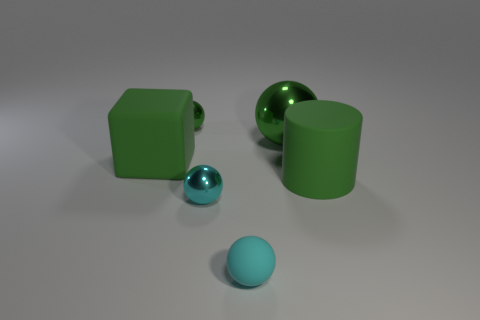How big is the matte sphere?
Your answer should be compact. Small. There is a green object that is on the left side of the cyan shiny sphere and behind the big green cube; what shape is it?
Give a very brief answer. Sphere. What is the color of the other large thing that is the same shape as the cyan matte object?
Provide a short and direct response. Green. How many things are either green shiny balls that are in front of the small green object or metal balls on the right side of the green matte cube?
Provide a succinct answer. 3. What is the shape of the big green metallic object?
Ensure brevity in your answer.  Sphere. The large rubber thing that is the same color as the big cube is what shape?
Give a very brief answer. Cylinder. How many other blocks are the same material as the block?
Your response must be concise. 0. The large metal sphere is what color?
Your response must be concise. Green. There is a metallic thing that is the same size as the rubber block; what is its color?
Offer a very short reply. Green. Are there any balls of the same color as the large cylinder?
Offer a very short reply. Yes. 